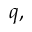<formula> <loc_0><loc_0><loc_500><loc_500>q ,</formula> 